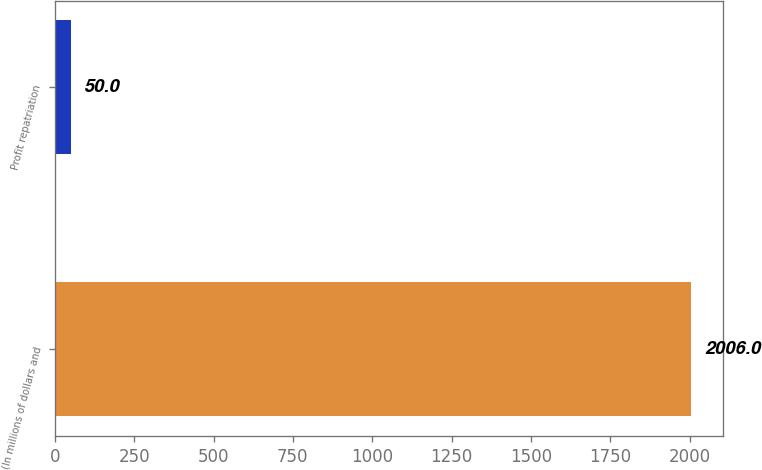Convert chart to OTSL. <chart><loc_0><loc_0><loc_500><loc_500><bar_chart><fcel>(In millions of dollars and<fcel>Profit repatriation<nl><fcel>2006<fcel>50<nl></chart> 